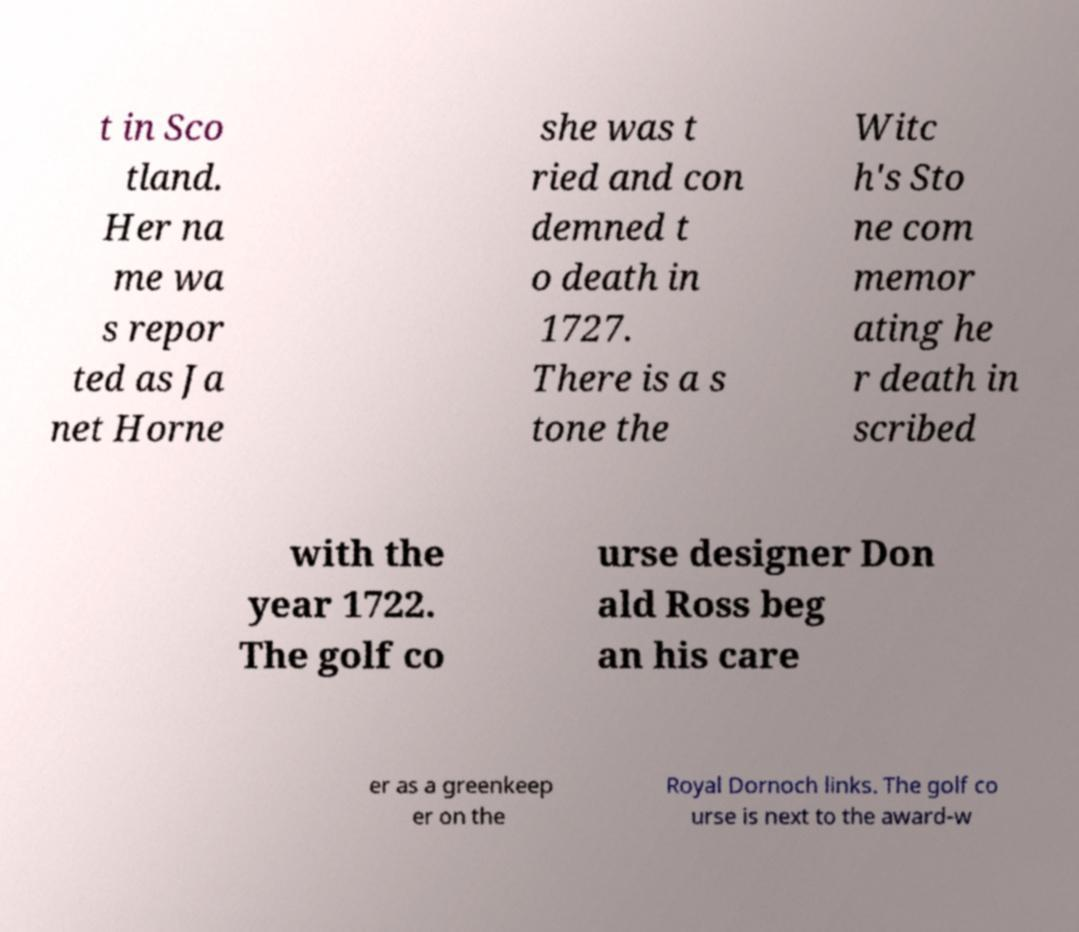Can you accurately transcribe the text from the provided image for me? t in Sco tland. Her na me wa s repor ted as Ja net Horne she was t ried and con demned t o death in 1727. There is a s tone the Witc h's Sto ne com memor ating he r death in scribed with the year 1722. The golf co urse designer Don ald Ross beg an his care er as a greenkeep er on the Royal Dornoch links. The golf co urse is next to the award-w 